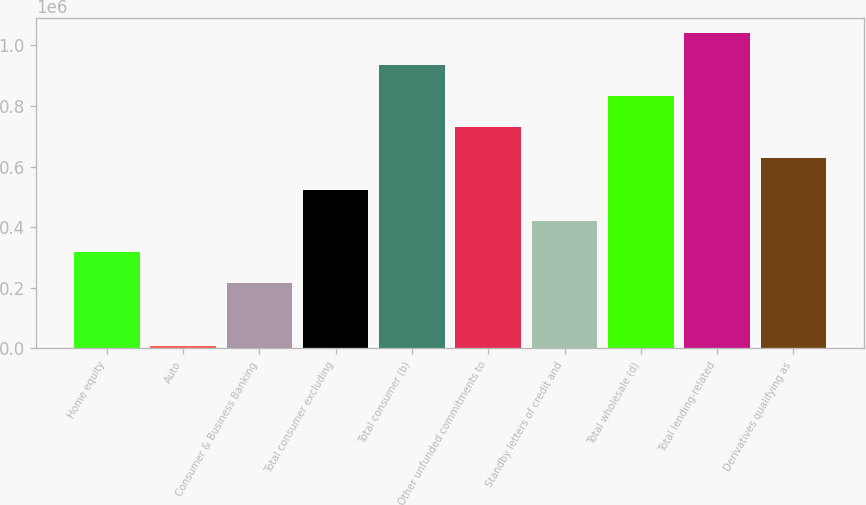Convert chart to OTSL. <chart><loc_0><loc_0><loc_500><loc_500><bar_chart><fcel>Home equity<fcel>Auto<fcel>Consumer & Business Banking<fcel>Total consumer excluding<fcel>Total consumer (b)<fcel>Other unfunded commitments to<fcel>Standby letters of credit and<fcel>Total wholesale (d)<fcel>Total lending-related<fcel>Derivatives qualifying as<nl><fcel>317385<fcel>8011<fcel>214260<fcel>523634<fcel>936133<fcel>729884<fcel>420510<fcel>833009<fcel>1.03926e+06<fcel>626759<nl></chart> 